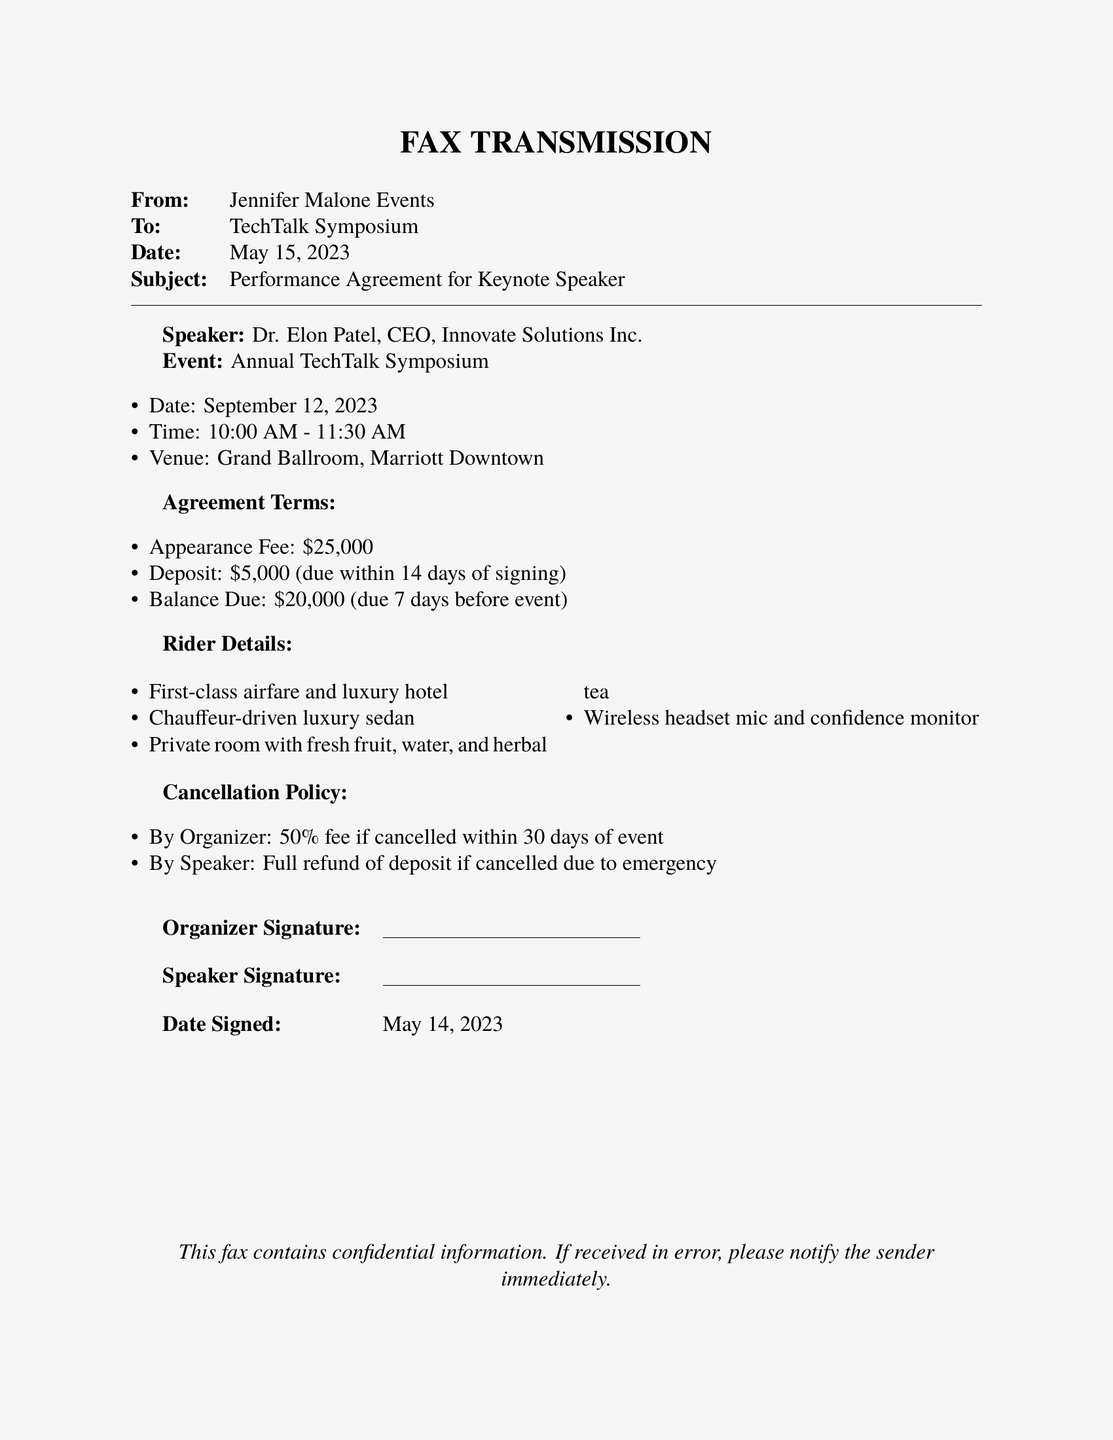What is the speaker's name? The speaker's name is explicitly mentioned in the document as Dr. Elon Patel.
Answer: Dr. Elon Patel What is the appearance fee for the keynote speaker? The document clearly states the appearance fee which is $25,000.
Answer: $25,000 When is the event scheduled to take place? The date of the event is listed in the document as September 12, 2023.
Answer: September 12, 2023 What is the deposit amount due upon signing? The document specifies that the deposit due within 14 days of signing is $5,000.
Answer: $5,000 What is the cancellation policy for the organizer? The organizer has a cancellation fee of 50% if cancelled within 30 days of the event, as stated in the document.
Answer: 50% What does the speaker require for travel accommodations? The rider details include first-class airfare and luxury hotel as required accommodations.
Answer: First-class airfare and luxury hotel How long is the keynote speaker scheduled to speak? The time allocated for the speaker's presentation is indicated in the document as 1 hour and 30 minutes.
Answer: 1 hour and 30 minutes What is the date signed on the performance agreement? The date signed on the agreement is explicitly noted as May 14, 2023.
Answer: May 14, 2023 What type of transportation is included in the rider details? The rider details mention a chauffeur-driven luxury sedan for transportation.
Answer: Chauffeur-driven luxury sedan 